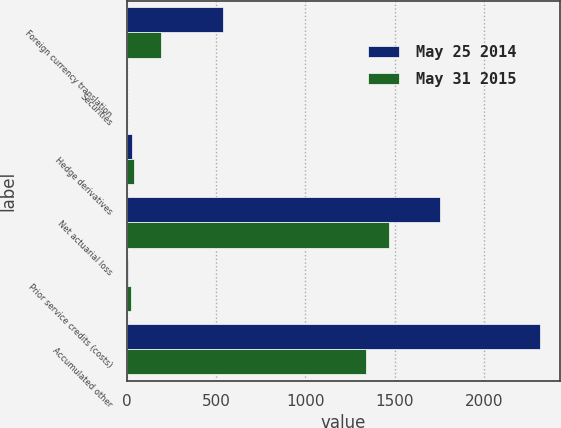Convert chart. <chart><loc_0><loc_0><loc_500><loc_500><stacked_bar_chart><ecel><fcel>Foreign currency translation<fcel>Securities<fcel>Hedge derivatives<fcel>Net actuarial loss<fcel>Prior service credits (costs)<fcel>Accumulated other<nl><fcel>May 25 2014<fcel>536.6<fcel>3.7<fcel>28.8<fcel>1756.1<fcel>7.1<fcel>2310.7<nl><fcel>May 31 2015<fcel>191.3<fcel>2.9<fcel>38.8<fcel>1469.2<fcel>26.5<fcel>1340.3<nl></chart> 